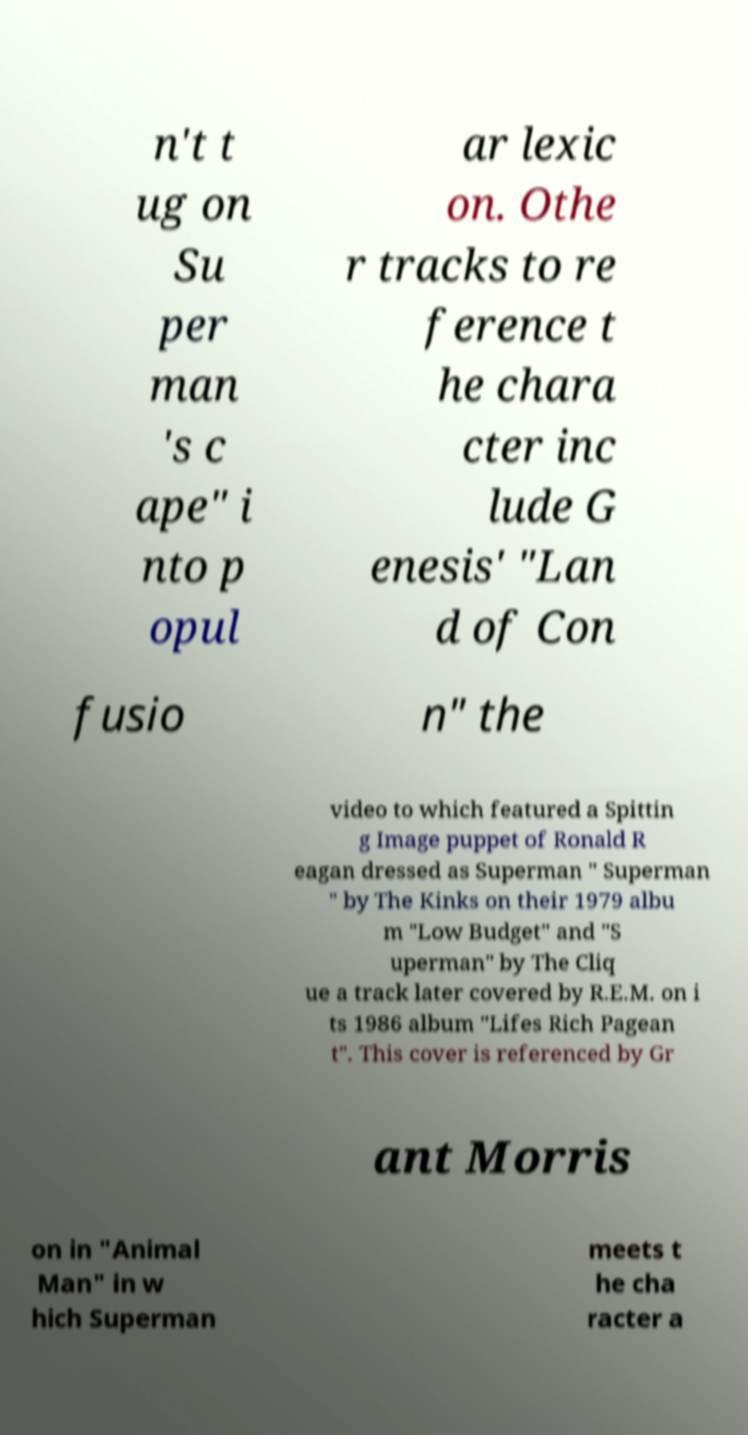Please read and relay the text visible in this image. What does it say? n't t ug on Su per man 's c ape" i nto p opul ar lexic on. Othe r tracks to re ference t he chara cter inc lude G enesis' "Lan d of Con fusio n" the video to which featured a Spittin g Image puppet of Ronald R eagan dressed as Superman " Superman " by The Kinks on their 1979 albu m "Low Budget" and "S uperman" by The Cliq ue a track later covered by R.E.M. on i ts 1986 album "Lifes Rich Pagean t". This cover is referenced by Gr ant Morris on in "Animal Man" in w hich Superman meets t he cha racter a 